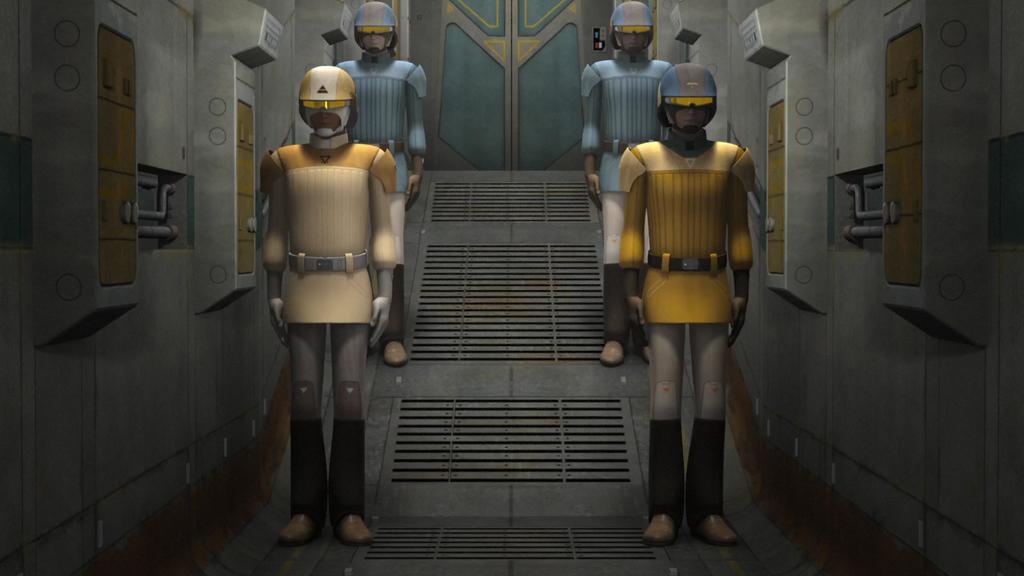In one or two sentences, can you explain what this image depicts? This is an animated image. In this image we can see depictions of persons. In the background of the image there is a door. 